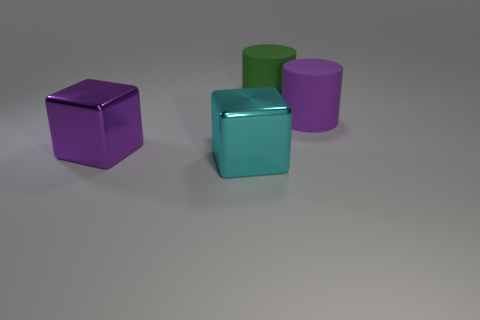What materials could these objects be made of if they were real? Given their looks, the purple cube and cylinder resemble objects with a matte finish, potentially made of a material like plastic or painted wood. The cyan cube, with its reflective surface, suggests a metallic material, perhaps anodized aluminum for lightweight construction, or even colored glass for an artistic piece. Each material choice would add its unique tactile and visual experience to the objects. 